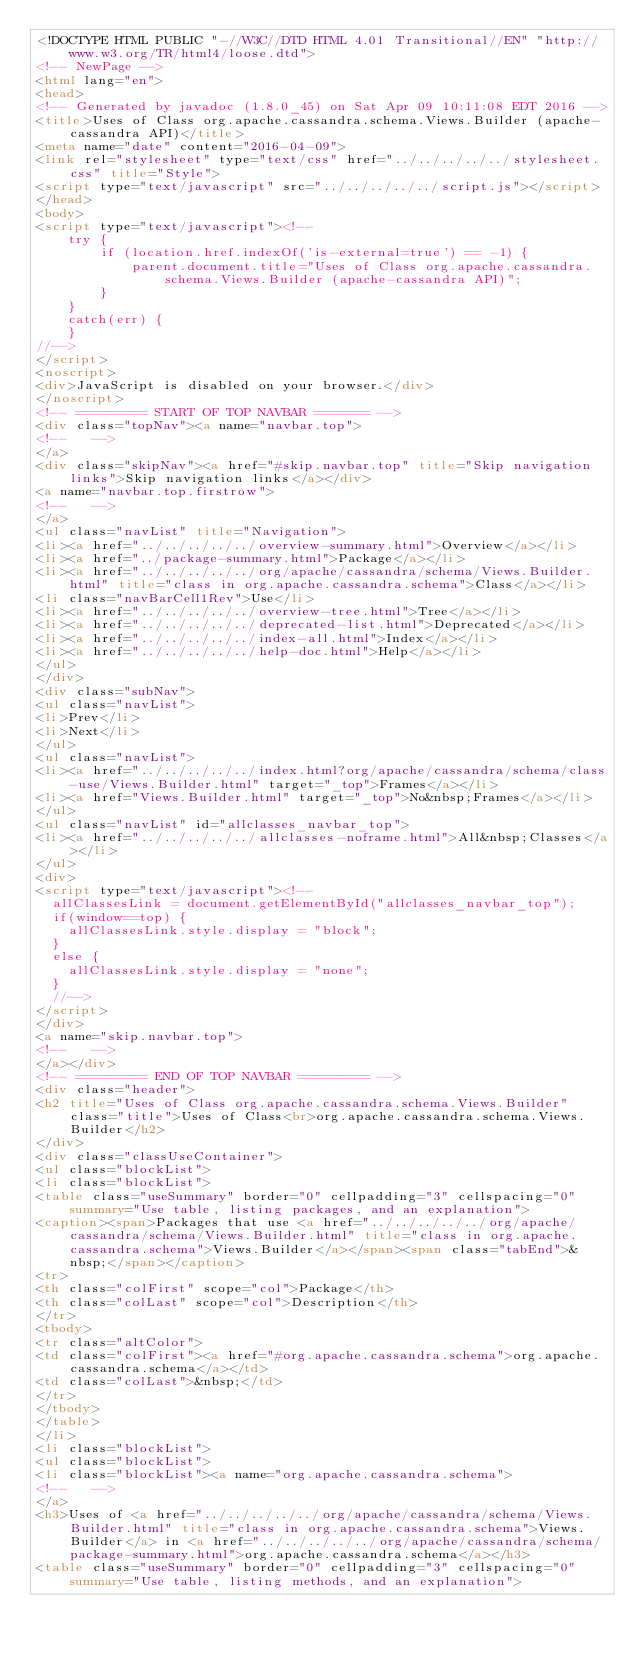Convert code to text. <code><loc_0><loc_0><loc_500><loc_500><_HTML_><!DOCTYPE HTML PUBLIC "-//W3C//DTD HTML 4.01 Transitional//EN" "http://www.w3.org/TR/html4/loose.dtd">
<!-- NewPage -->
<html lang="en">
<head>
<!-- Generated by javadoc (1.8.0_45) on Sat Apr 09 10:11:08 EDT 2016 -->
<title>Uses of Class org.apache.cassandra.schema.Views.Builder (apache-cassandra API)</title>
<meta name="date" content="2016-04-09">
<link rel="stylesheet" type="text/css" href="../../../../../stylesheet.css" title="Style">
<script type="text/javascript" src="../../../../../script.js"></script>
</head>
<body>
<script type="text/javascript"><!--
    try {
        if (location.href.indexOf('is-external=true') == -1) {
            parent.document.title="Uses of Class org.apache.cassandra.schema.Views.Builder (apache-cassandra API)";
        }
    }
    catch(err) {
    }
//-->
</script>
<noscript>
<div>JavaScript is disabled on your browser.</div>
</noscript>
<!-- ========= START OF TOP NAVBAR ======= -->
<div class="topNav"><a name="navbar.top">
<!--   -->
</a>
<div class="skipNav"><a href="#skip.navbar.top" title="Skip navigation links">Skip navigation links</a></div>
<a name="navbar.top.firstrow">
<!--   -->
</a>
<ul class="navList" title="Navigation">
<li><a href="../../../../../overview-summary.html">Overview</a></li>
<li><a href="../package-summary.html">Package</a></li>
<li><a href="../../../../../org/apache/cassandra/schema/Views.Builder.html" title="class in org.apache.cassandra.schema">Class</a></li>
<li class="navBarCell1Rev">Use</li>
<li><a href="../../../../../overview-tree.html">Tree</a></li>
<li><a href="../../../../../deprecated-list.html">Deprecated</a></li>
<li><a href="../../../../../index-all.html">Index</a></li>
<li><a href="../../../../../help-doc.html">Help</a></li>
</ul>
</div>
<div class="subNav">
<ul class="navList">
<li>Prev</li>
<li>Next</li>
</ul>
<ul class="navList">
<li><a href="../../../../../index.html?org/apache/cassandra/schema/class-use/Views.Builder.html" target="_top">Frames</a></li>
<li><a href="Views.Builder.html" target="_top">No&nbsp;Frames</a></li>
</ul>
<ul class="navList" id="allclasses_navbar_top">
<li><a href="../../../../../allclasses-noframe.html">All&nbsp;Classes</a></li>
</ul>
<div>
<script type="text/javascript"><!--
  allClassesLink = document.getElementById("allclasses_navbar_top");
  if(window==top) {
    allClassesLink.style.display = "block";
  }
  else {
    allClassesLink.style.display = "none";
  }
  //-->
</script>
</div>
<a name="skip.navbar.top">
<!--   -->
</a></div>
<!-- ========= END OF TOP NAVBAR ========= -->
<div class="header">
<h2 title="Uses of Class org.apache.cassandra.schema.Views.Builder" class="title">Uses of Class<br>org.apache.cassandra.schema.Views.Builder</h2>
</div>
<div class="classUseContainer">
<ul class="blockList">
<li class="blockList">
<table class="useSummary" border="0" cellpadding="3" cellspacing="0" summary="Use table, listing packages, and an explanation">
<caption><span>Packages that use <a href="../../../../../org/apache/cassandra/schema/Views.Builder.html" title="class in org.apache.cassandra.schema">Views.Builder</a></span><span class="tabEnd">&nbsp;</span></caption>
<tr>
<th class="colFirst" scope="col">Package</th>
<th class="colLast" scope="col">Description</th>
</tr>
<tbody>
<tr class="altColor">
<td class="colFirst"><a href="#org.apache.cassandra.schema">org.apache.cassandra.schema</a></td>
<td class="colLast">&nbsp;</td>
</tr>
</tbody>
</table>
</li>
<li class="blockList">
<ul class="blockList">
<li class="blockList"><a name="org.apache.cassandra.schema">
<!--   -->
</a>
<h3>Uses of <a href="../../../../../org/apache/cassandra/schema/Views.Builder.html" title="class in org.apache.cassandra.schema">Views.Builder</a> in <a href="../../../../../org/apache/cassandra/schema/package-summary.html">org.apache.cassandra.schema</a></h3>
<table class="useSummary" border="0" cellpadding="3" cellspacing="0" summary="Use table, listing methods, and an explanation"></code> 